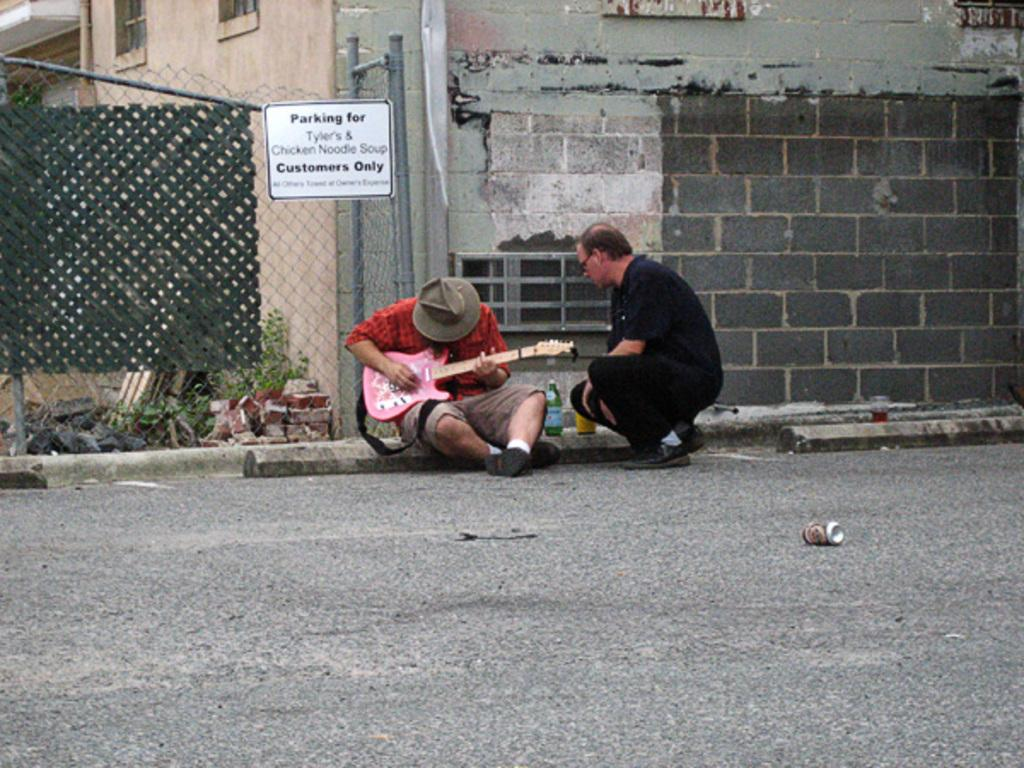What are the two persons in the image doing? There are two persons sitting on the road, and one of them is playing a guitar. Can you describe the person playing the guitar? The person playing the guitar is wearing a cap. What can be seen in the background of the image? There is a wall in the background of the image. What other objects are visible in the image? There is a bottle and a board visible in the image. What type of religion is being practiced by the person playing the guitar in the image? There is no indication of any religious practice in the image; it simply shows a person playing a guitar while sitting on the road. What position is the guitar being held in by the person playing it? The image does not provide enough detail to determine the exact position of the guitar, but it is clear that the person is playing it. 